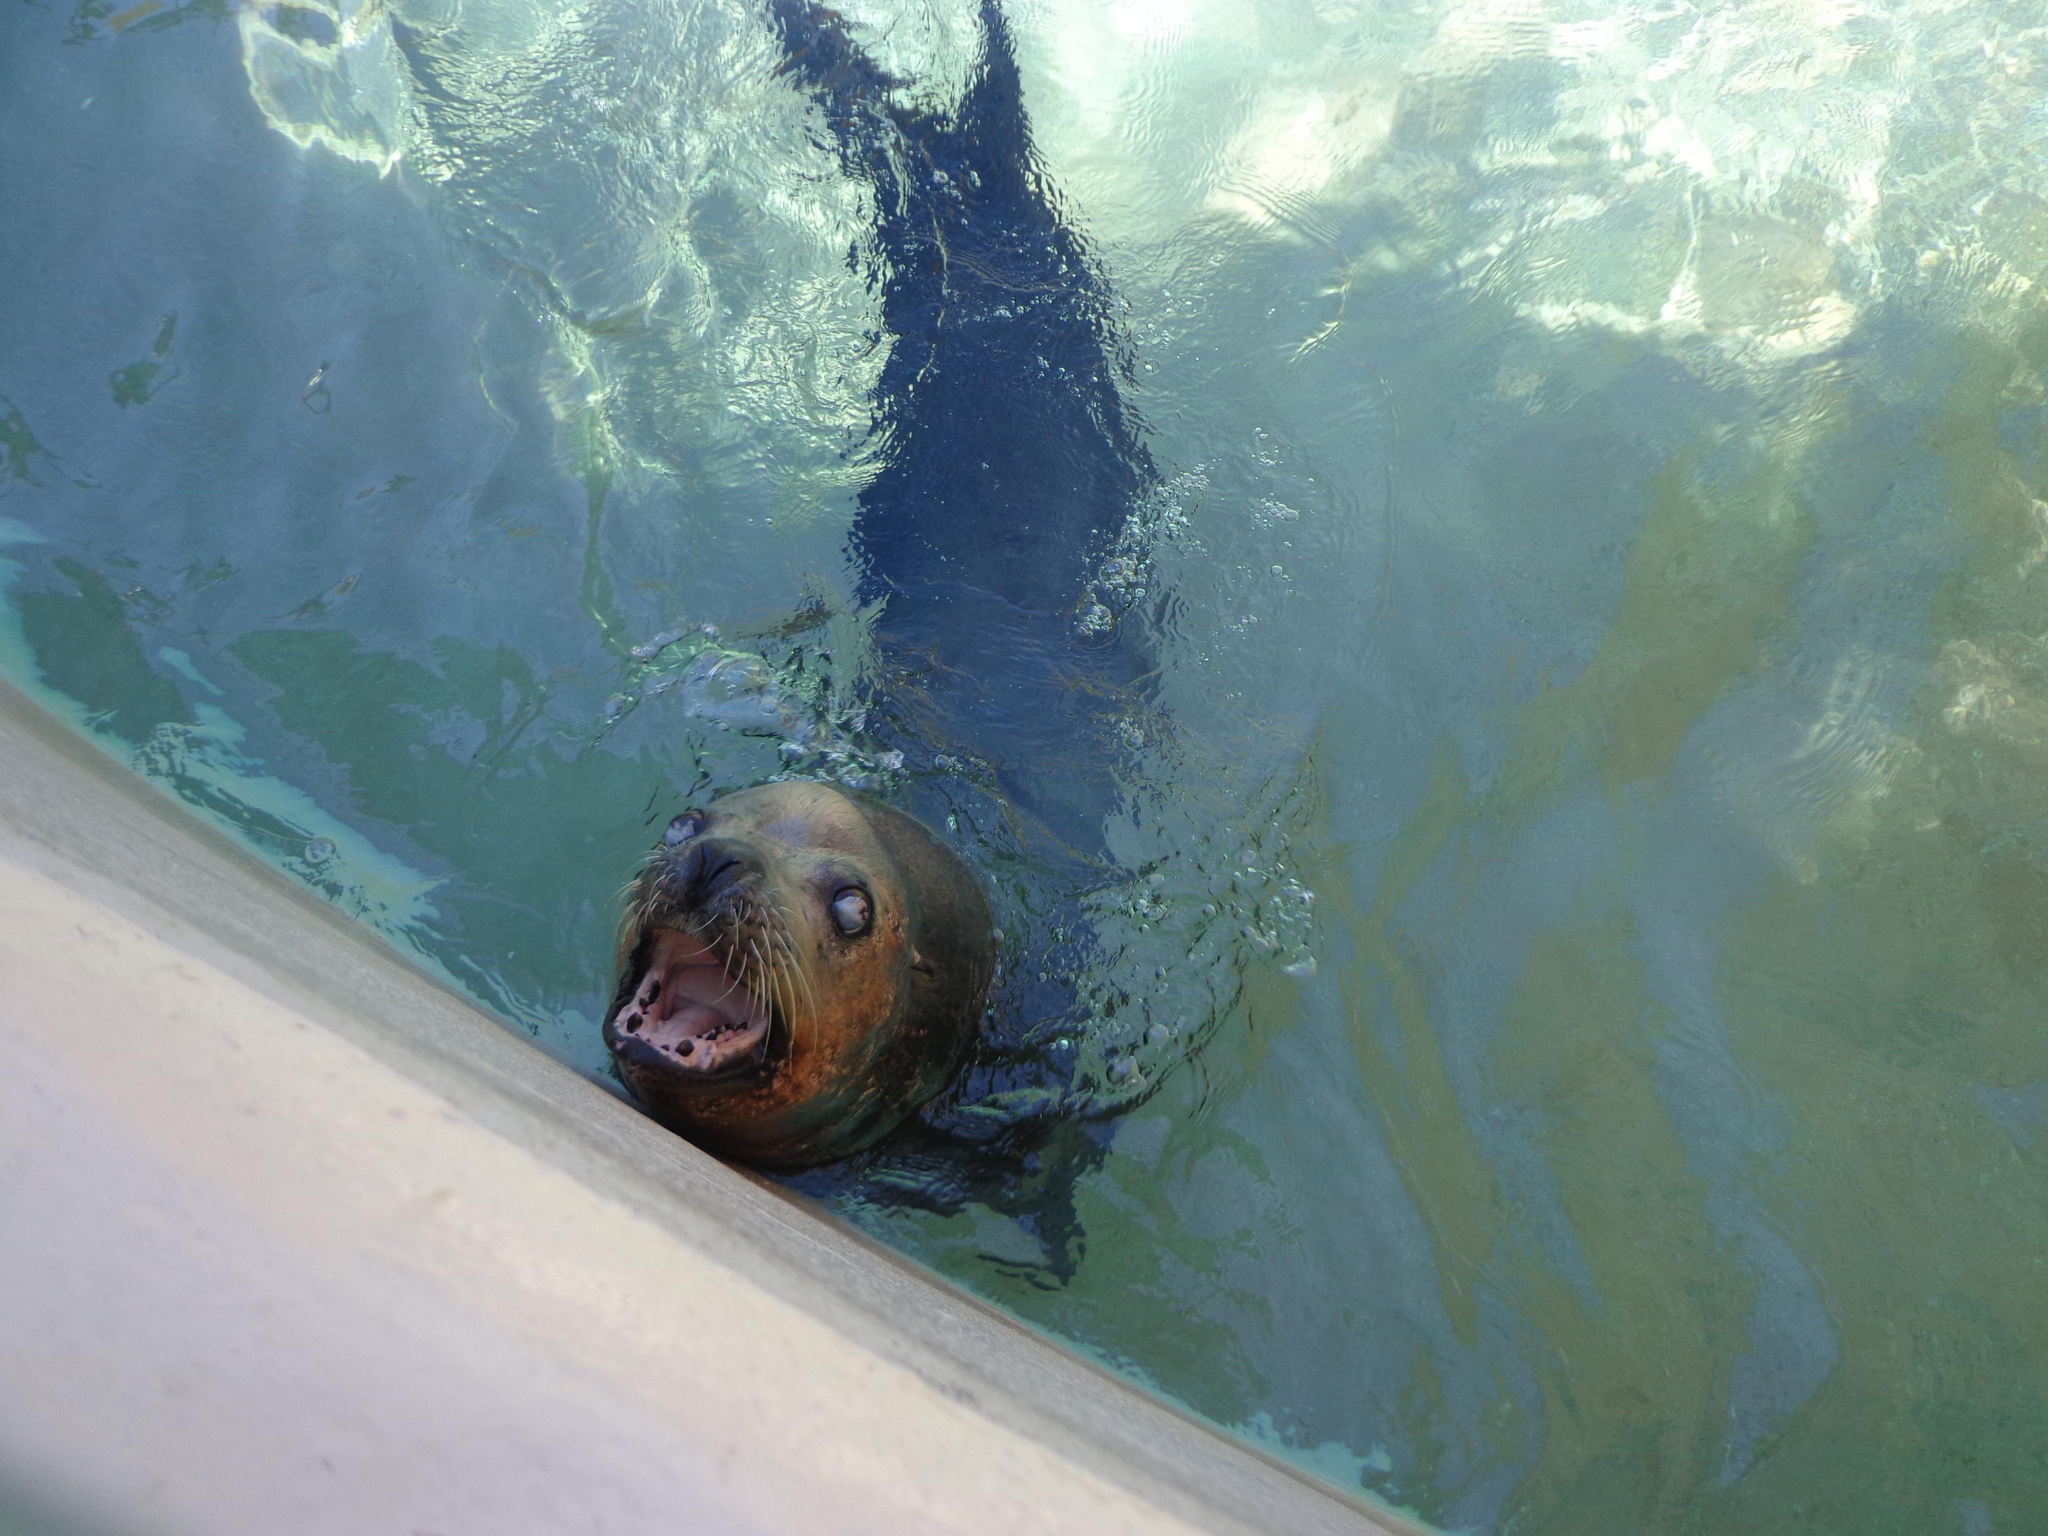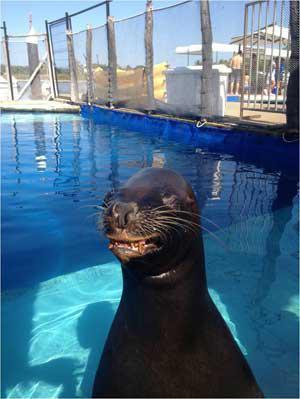The first image is the image on the left, the second image is the image on the right. For the images displayed, is the sentence "At least one of the seals is in the water." factually correct? Answer yes or no. Yes. The first image is the image on the left, the second image is the image on the right. Examine the images to the left and right. Is the description "An image includes one reclining seal next to a seal with raised head and shoulders." accurate? Answer yes or no. No. 